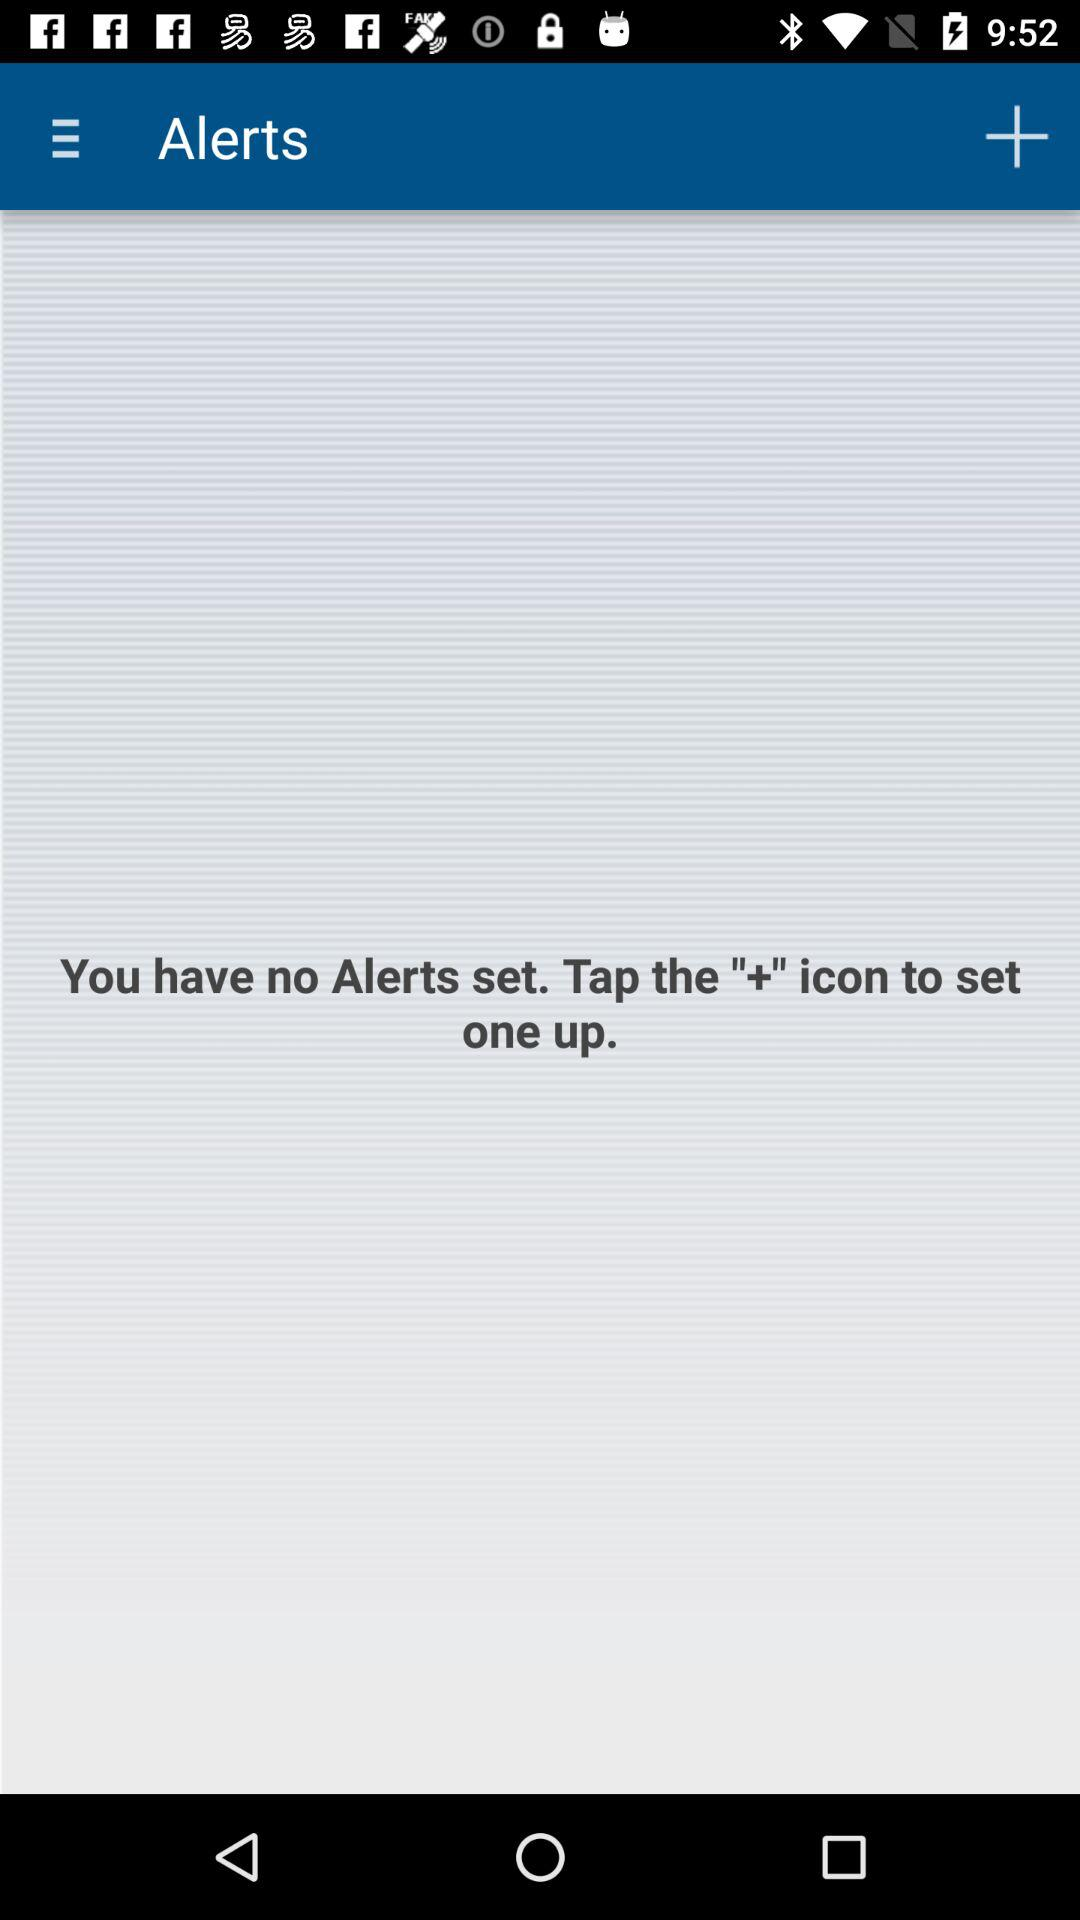What to do to set the alert? You have to tap the "+" icon to set the alert. 